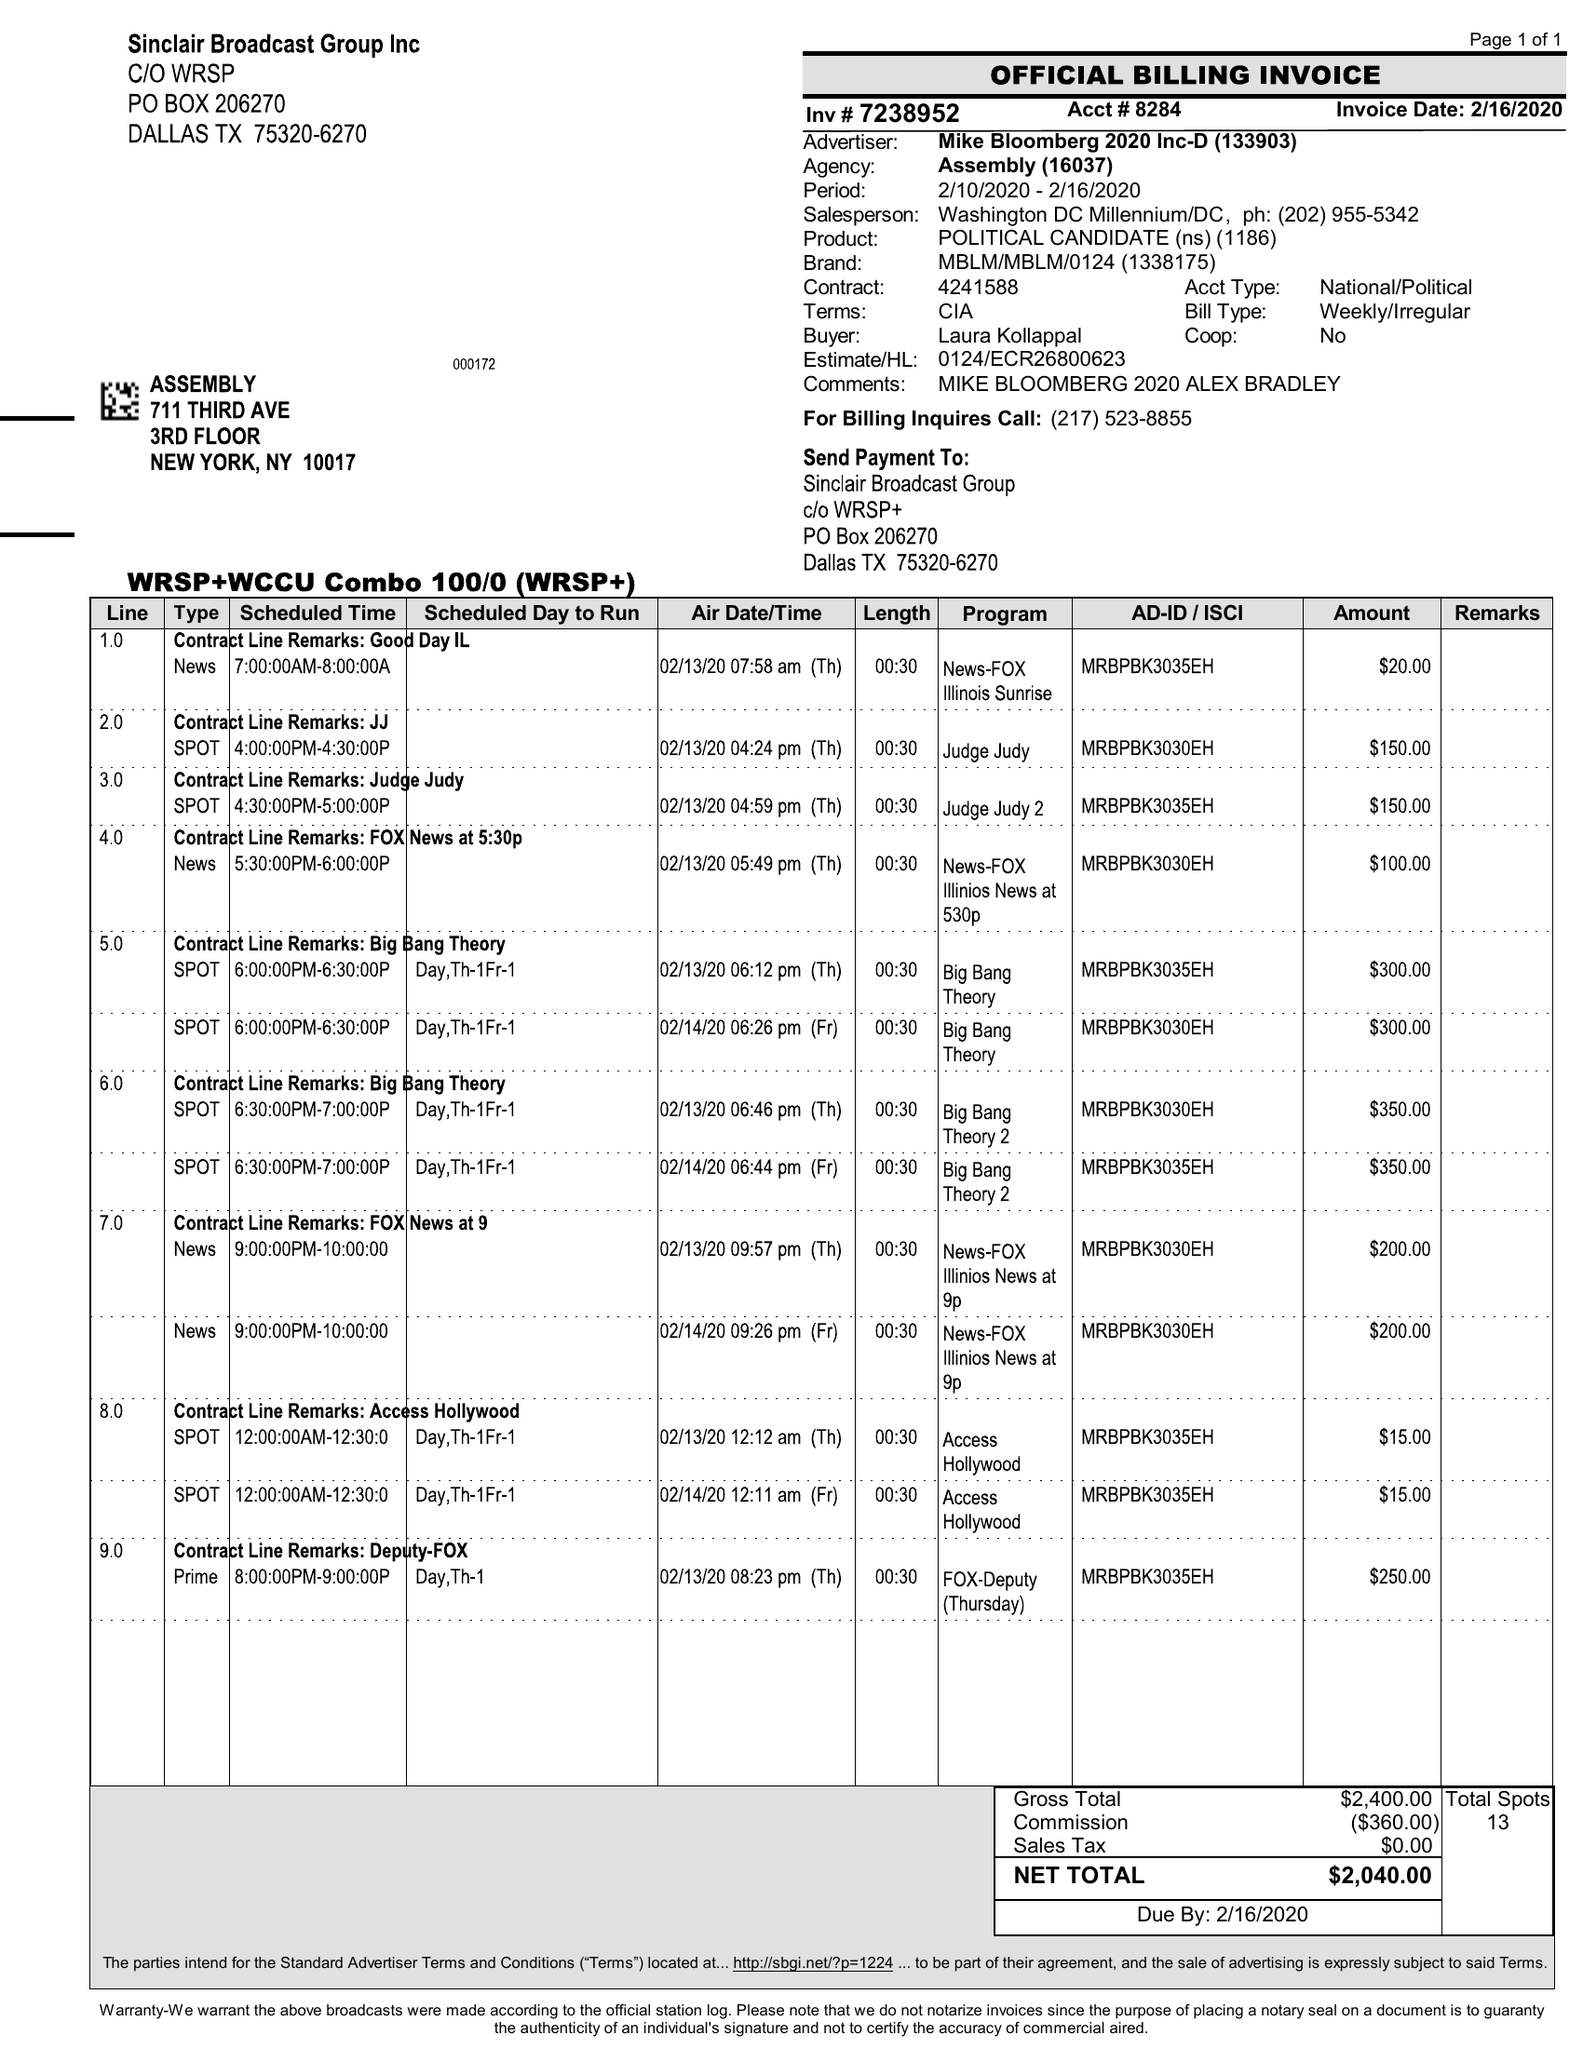What is the value for the gross_amount?
Answer the question using a single word or phrase. 2400.00 